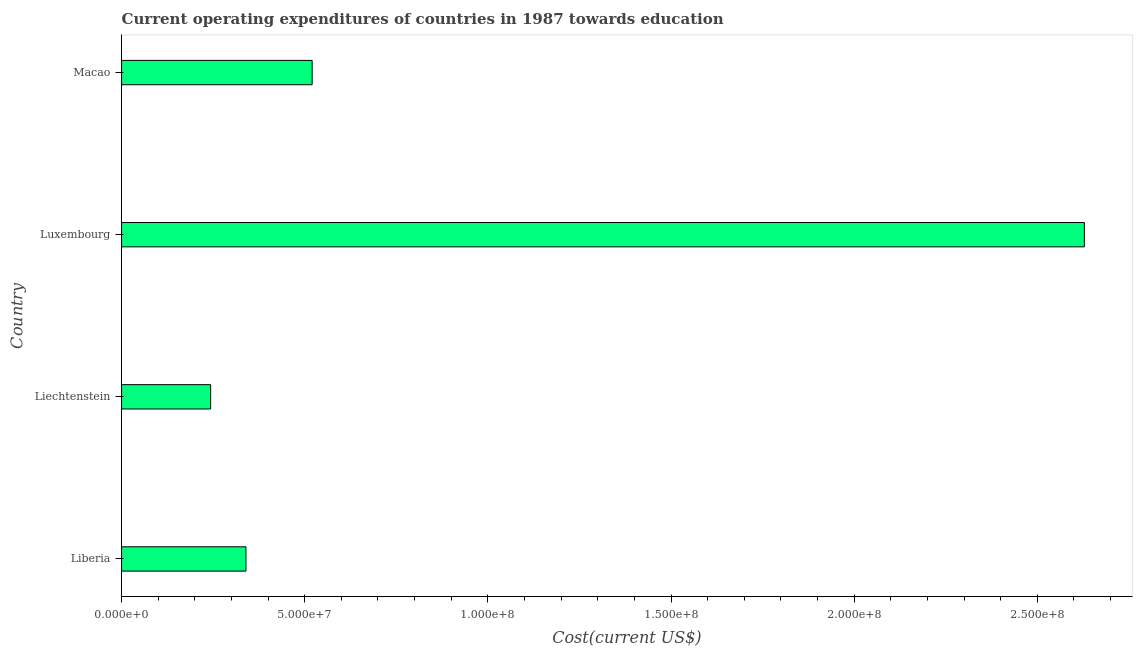What is the title of the graph?
Your answer should be compact. Current operating expenditures of countries in 1987 towards education. What is the label or title of the X-axis?
Your response must be concise. Cost(current US$). What is the education expenditure in Liberia?
Provide a succinct answer. 3.40e+07. Across all countries, what is the maximum education expenditure?
Your response must be concise. 2.63e+08. Across all countries, what is the minimum education expenditure?
Offer a very short reply. 2.43e+07. In which country was the education expenditure maximum?
Make the answer very short. Luxembourg. In which country was the education expenditure minimum?
Your response must be concise. Liechtenstein. What is the sum of the education expenditure?
Offer a very short reply. 3.73e+08. What is the difference between the education expenditure in Liberia and Luxembourg?
Make the answer very short. -2.29e+08. What is the average education expenditure per country?
Your answer should be very brief. 9.33e+07. What is the median education expenditure?
Ensure brevity in your answer.  4.30e+07. In how many countries, is the education expenditure greater than 180000000 US$?
Your response must be concise. 1. What is the ratio of the education expenditure in Liechtenstein to that in Luxembourg?
Offer a very short reply. 0.09. What is the difference between the highest and the second highest education expenditure?
Provide a succinct answer. 2.11e+08. Is the sum of the education expenditure in Liberia and Liechtenstein greater than the maximum education expenditure across all countries?
Your response must be concise. No. What is the difference between the highest and the lowest education expenditure?
Offer a very short reply. 2.39e+08. How many countries are there in the graph?
Provide a short and direct response. 4. What is the difference between two consecutive major ticks on the X-axis?
Make the answer very short. 5.00e+07. What is the Cost(current US$) in Liberia?
Your answer should be compact. 3.40e+07. What is the Cost(current US$) of Liechtenstein?
Provide a succinct answer. 2.43e+07. What is the Cost(current US$) of Luxembourg?
Give a very brief answer. 2.63e+08. What is the Cost(current US$) in Macao?
Ensure brevity in your answer.  5.20e+07. What is the difference between the Cost(current US$) in Liberia and Liechtenstein?
Your answer should be very brief. 9.64e+06. What is the difference between the Cost(current US$) in Liberia and Luxembourg?
Provide a succinct answer. -2.29e+08. What is the difference between the Cost(current US$) in Liberia and Macao?
Offer a very short reply. -1.81e+07. What is the difference between the Cost(current US$) in Liechtenstein and Luxembourg?
Provide a succinct answer. -2.39e+08. What is the difference between the Cost(current US$) in Liechtenstein and Macao?
Offer a terse response. -2.77e+07. What is the difference between the Cost(current US$) in Luxembourg and Macao?
Ensure brevity in your answer.  2.11e+08. What is the ratio of the Cost(current US$) in Liberia to that in Liechtenstein?
Give a very brief answer. 1.4. What is the ratio of the Cost(current US$) in Liberia to that in Luxembourg?
Ensure brevity in your answer.  0.13. What is the ratio of the Cost(current US$) in Liberia to that in Macao?
Your answer should be very brief. 0.65. What is the ratio of the Cost(current US$) in Liechtenstein to that in Luxembourg?
Offer a terse response. 0.09. What is the ratio of the Cost(current US$) in Liechtenstein to that in Macao?
Your answer should be compact. 0.47. What is the ratio of the Cost(current US$) in Luxembourg to that in Macao?
Provide a short and direct response. 5.05. 